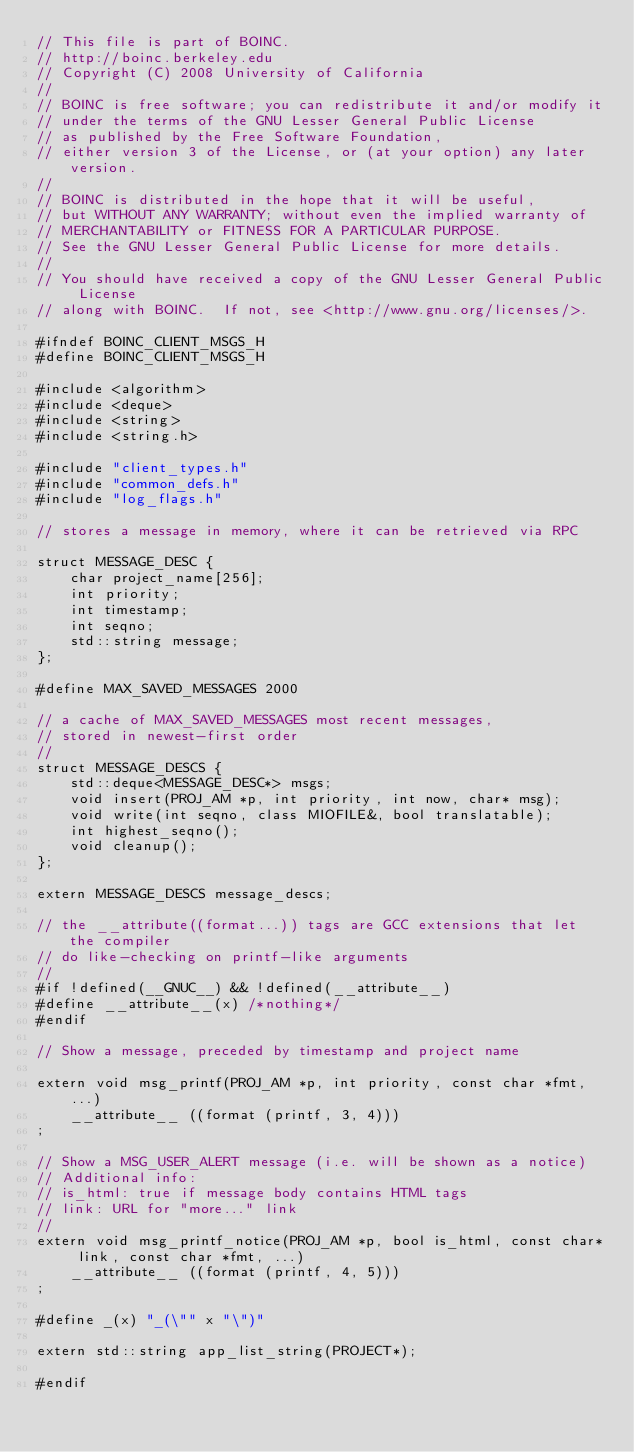<code> <loc_0><loc_0><loc_500><loc_500><_C_>// This file is part of BOINC.
// http://boinc.berkeley.edu
// Copyright (C) 2008 University of California
//
// BOINC is free software; you can redistribute it and/or modify it
// under the terms of the GNU Lesser General Public License
// as published by the Free Software Foundation,
// either version 3 of the License, or (at your option) any later version.
//
// BOINC is distributed in the hope that it will be useful,
// but WITHOUT ANY WARRANTY; without even the implied warranty of
// MERCHANTABILITY or FITNESS FOR A PARTICULAR PURPOSE.
// See the GNU Lesser General Public License for more details.
//
// You should have received a copy of the GNU Lesser General Public License
// along with BOINC.  If not, see <http://www.gnu.org/licenses/>.

#ifndef BOINC_CLIENT_MSGS_H
#define BOINC_CLIENT_MSGS_H

#include <algorithm>
#include <deque>
#include <string>
#include <string.h>

#include "client_types.h"
#include "common_defs.h"
#include "log_flags.h"

// stores a message in memory, where it can be retrieved via RPC

struct MESSAGE_DESC {
    char project_name[256];
    int priority;
    int timestamp;
    int seqno;
    std::string message;
};

#define MAX_SAVED_MESSAGES 2000

// a cache of MAX_SAVED_MESSAGES most recent messages,
// stored in newest-first order
//
struct MESSAGE_DESCS {
    std::deque<MESSAGE_DESC*> msgs;
    void insert(PROJ_AM *p, int priority, int now, char* msg);
    void write(int seqno, class MIOFILE&, bool translatable);
    int highest_seqno();
    void cleanup();
};

extern MESSAGE_DESCS message_descs;

// the __attribute((format...)) tags are GCC extensions that let the compiler
// do like-checking on printf-like arguments
//
#if !defined(__GNUC__) && !defined(__attribute__)
#define __attribute__(x) /*nothing*/
#endif

// Show a message, preceded by timestamp and project name

extern void msg_printf(PROJ_AM *p, int priority, const char *fmt, ...)
    __attribute__ ((format (printf, 3, 4)))
;

// Show a MSG_USER_ALERT message (i.e. will be shown as a notice)
// Additional info:
// is_html: true if message body contains HTML tags
// link: URL for "more..." link
//
extern void msg_printf_notice(PROJ_AM *p, bool is_html, const char* link, const char *fmt, ...)
    __attribute__ ((format (printf, 4, 5)))
;

#define _(x) "_(\"" x "\")"

extern std::string app_list_string(PROJECT*);

#endif
</code> 